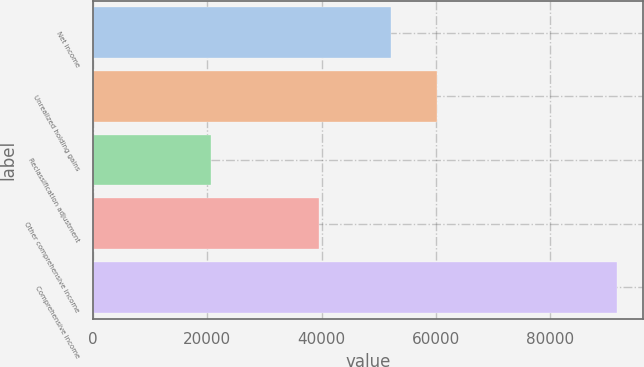Convert chart to OTSL. <chart><loc_0><loc_0><loc_500><loc_500><bar_chart><fcel>Net income<fcel>Unrealized holding gains<fcel>Reclassification adjustment<fcel>Other comprehensive income<fcel>Comprehensive income<nl><fcel>52198<fcel>60196<fcel>20606<fcel>39590<fcel>91788<nl></chart> 